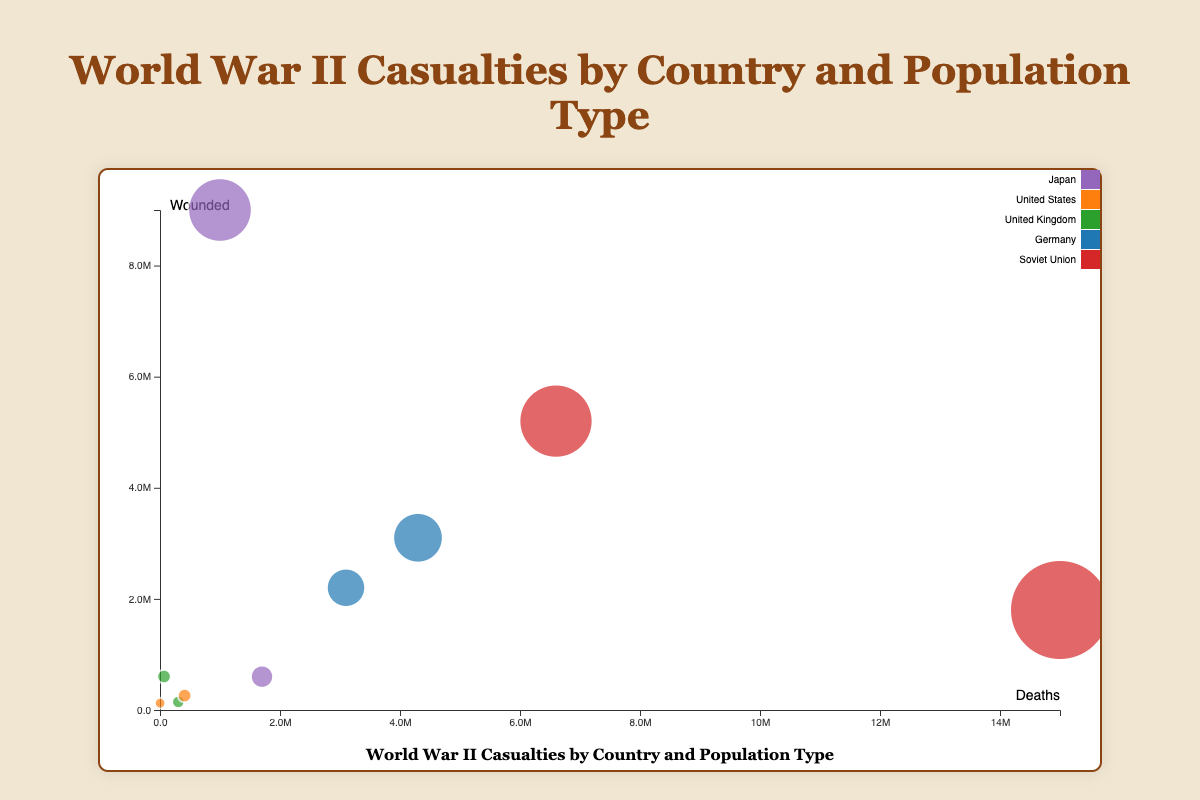How many countries are represented in the chart? By looking at the legend on the right side of the bubble chart, each country is assigned a unique color. The legend lists 5 different countries.
Answer: 5 Which country has the largest bubble in the chart? The largest bubble size corresponds to the highest number of casualties. The bubble associated with the Soviet Union represents the highest total number of casualties (16,800,000 for civilians).
Answer: Soviet Union What is the total number of casualties for military personnel in Germany aged 18-25? There is a bubble for Germany's military personnel aged 18-25, totaling 5,300,000 casualties.
Answer: 5,300,000 Which country has more deaths among civilians, Soviet Union or Germany? By comparing the bubbles for civilian populations, the Soviet Union has 15,000,000 deaths, whereas Germany has 4,300,000 deaths.
Answer: Soviet Union What is the ratio of wounded to deaths for United Kingdom civilians? United Kingdom civilians have 67,000 deaths and 603,000 wounded. The ratio is calculated as 603,000/67,000 ≈ 9.
Answer: 9 How does the number of wounded civilians in Japan compare to the number of wounded civilians in the Soviet Union? Japan has 9,000,000 wounded civilians, while the Soviet Union has 1,800,000 wounded civilians. Comparing these, Japan has significantly more wounded civilians.
Answer: Japan has more What is the smallest bubble on the chart, and to whom does it belong? The smallest bubble corresponds to the group with the smallest number of casualties. The bubble for United States civilian casualties (125,000) is the smallest.
Answer: United States civilians Which country has the highest number of military deaths aged 18-25? By looking at the bubbles representing the military population aged 18-25, the largest number comes from the Soviet Union with 6,600,000 deaths.
Answer: Soviet Union For which country is the ratio of military to civilian casualties the closest to 1:1? Calculate the ratios: Soviet Union (11,800,000 military: 16,800,000 civilian ≈ 0.7), Germany (5,300,000:7,400,000 ≈ 0.72), United Kingdom (450,000:670,000 ≈ 0.67), United States (670,000: 125,000 ≈ 5.4), Japan (2,300,000:10,000,000 ≈ 0.23). The closest to 1:1 is Germany.
Answer: Germany 